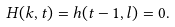Convert formula to latex. <formula><loc_0><loc_0><loc_500><loc_500>H ( k , t ) = h ( t - 1 , l ) = 0 .</formula> 